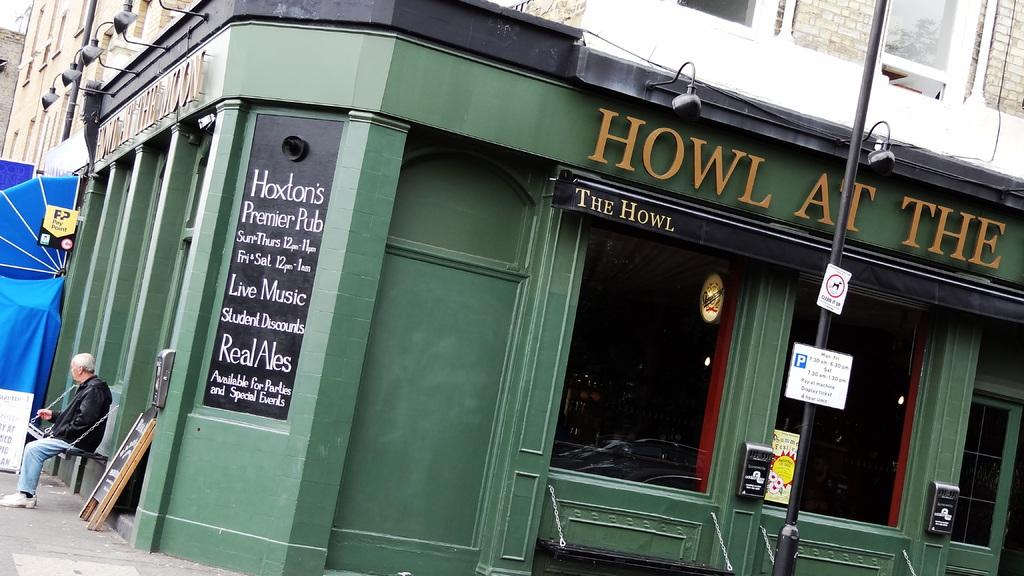What is the person in the image doing? There is a person sitting in the image. What objects can be seen in the image besides the person? There are boards, a pole, lights, and buildings in the image. Can you describe the pole in the image? The pole is a vertical structure that can be used for support or as a marker. What type of structures are visible in the image? There are buildings in the image. Is there a maid cleaning the boards in the image? There is no maid or cleaning activity involving the boards in the image. 